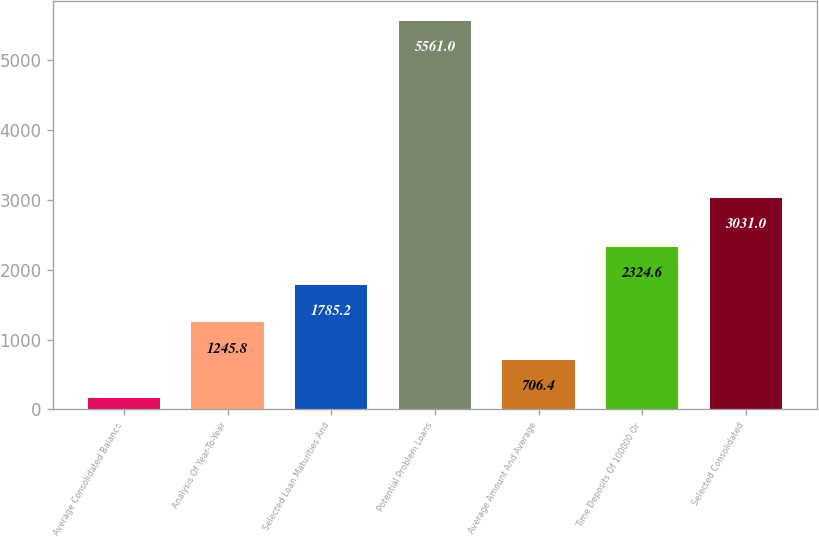Convert chart to OTSL. <chart><loc_0><loc_0><loc_500><loc_500><bar_chart><fcel>Average Consolidated Balance<fcel>Analysis Of Year-To-Year<fcel>Selected Loan Maturities And<fcel>Potential Problem Loans<fcel>Average Amount And Average<fcel>Time Deposits Of 100000 Or<fcel>Selected Consolidated<nl><fcel>167<fcel>1245.8<fcel>1785.2<fcel>5561<fcel>706.4<fcel>2324.6<fcel>3031<nl></chart> 